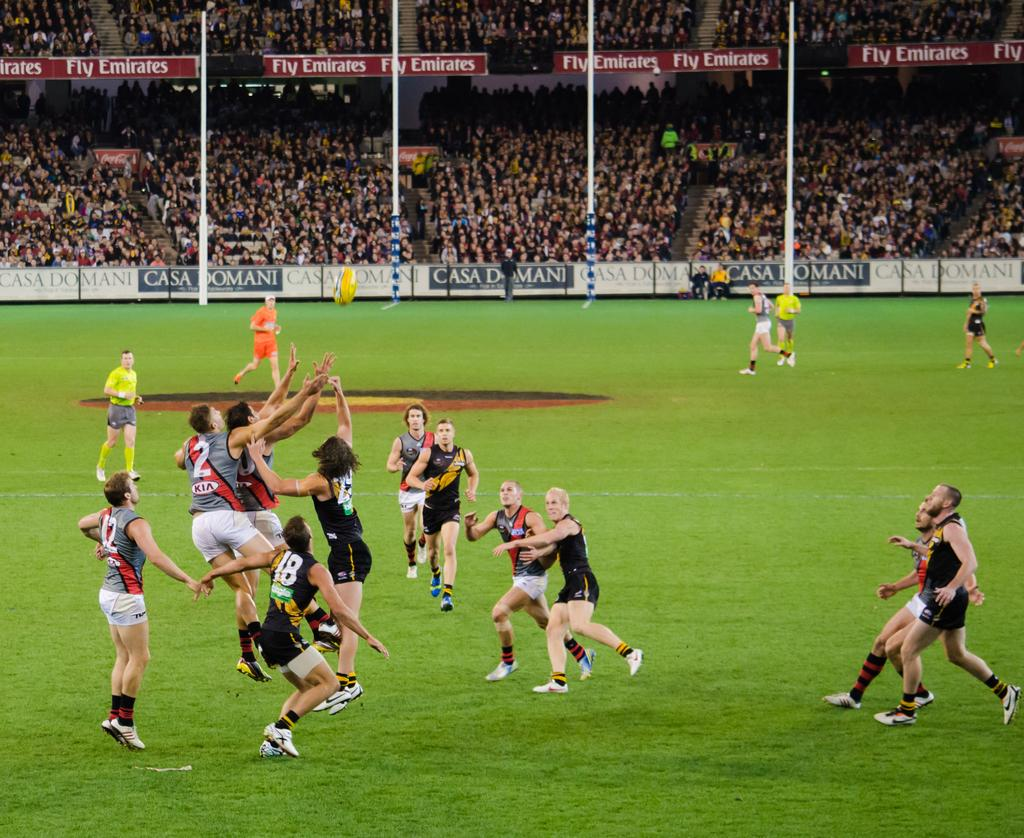Provide a one-sentence caption for the provided image. Players on the field playing rugby with a banner on the fence of Casa Domani. 